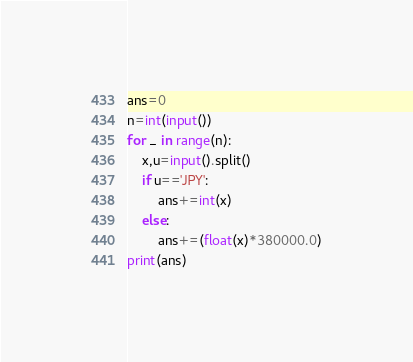<code> <loc_0><loc_0><loc_500><loc_500><_Python_>ans=0
n=int(input())
for _ in range(n):
    x,u=input().split()
    if u=='JPY':
        ans+=int(x)
    else:
        ans+=(float(x)*380000.0)
print(ans)</code> 